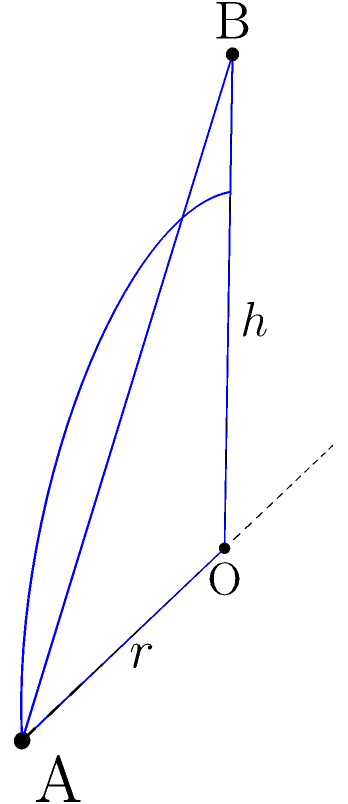In a resource-rich region, a conical pile of valuable minerals has been discovered. As a former diplomat experienced in resource-driven conflicts, you're tasked with estimating the volume of this mineral deposit. The pile has a circular base with a radius of 30 meters and a height of 40 meters. Calculate the volume of this conical pile of minerals in cubic meters. To solve this problem, we'll use the formula for the volume of a cone:

$$V = \frac{1}{3}\pi r^2 h$$

Where:
$V$ = volume of the cone
$r$ = radius of the base
$h$ = height of the cone

Given:
$r = 30$ meters
$h = 40$ meters

Step 1: Substitute the values into the formula:
$$V = \frac{1}{3}\pi (30\text{ m})^2 (40\text{ m})$$

Step 2: Simplify the expression inside the parentheses:
$$V = \frac{1}{3}\pi (900\text{ m}^2) (40\text{ m})$$

Step 3: Multiply the values:
$$V = \frac{1}{3}\pi (36,000\text{ m}^3)$$

Step 4: Multiply by $\frac{1}{3}$:
$$V = 12,000\pi\text{ m}^3$$

Step 5: Calculate the final value (rounded to the nearest whole number):
$$V \approx 37,699\text{ m}^3$$

This volume represents the estimated amount of minerals in the conical pile, which could be crucial information for resource allocation and conflict resolution in diplomatic negotiations.
Answer: $37,699\text{ m}^3$ 